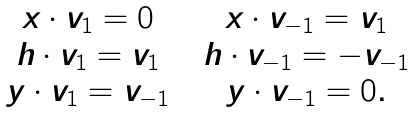<formula> <loc_0><loc_0><loc_500><loc_500>\begin{array} { c c c } x \cdot v _ { 1 } = 0 & & x \cdot v _ { - 1 } = v _ { 1 } \\ h \cdot v _ { 1 } = v _ { 1 } & & h \cdot v _ { - 1 } = - v _ { - 1 } \\ y \cdot v _ { 1 } = v _ { - 1 } & & y \cdot v _ { - 1 } = 0 . \end{array}</formula> 